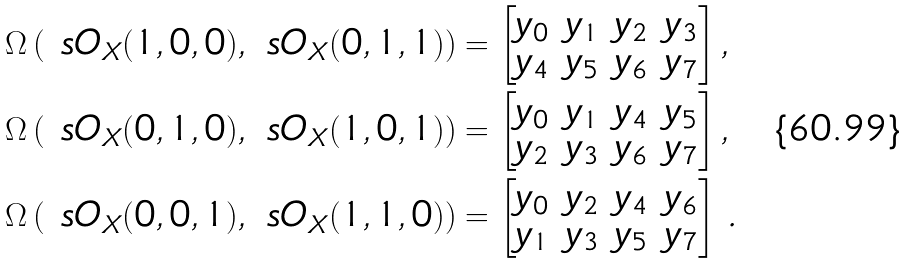Convert formula to latex. <formula><loc_0><loc_0><loc_500><loc_500>\Omega \left ( \ s O _ { X } ( 1 , 0 , 0 ) , \ s O _ { X } ( 0 , 1 , 1 ) \right ) & = \left [ \begin{matrix} y _ { 0 } & y _ { 1 } & y _ { 2 } & y _ { 3 } \\ y _ { 4 } & y _ { 5 } & y _ { 6 } & y _ { 7 } \end{matrix} \right ] , \\ \Omega \left ( \ s O _ { X } ( 0 , 1 , 0 ) , \ s O _ { X } ( 1 , 0 , 1 ) \right ) & = \left [ \begin{matrix} y _ { 0 } & y _ { 1 } & y _ { 4 } & y _ { 5 } \\ y _ { 2 } & y _ { 3 } & y _ { 6 } & y _ { 7 } \end{matrix} \right ] , \\ \Omega \left ( \ s O _ { X } ( 0 , 0 , 1 ) , \ s O _ { X } ( 1 , 1 , 0 ) \right ) & = \left [ \begin{matrix} y _ { 0 } & y _ { 2 } & y _ { 4 } & y _ { 6 } \\ y _ { 1 } & y _ { 3 } & y _ { 5 } & y _ { 7 } \end{matrix} \right ] \, .</formula> 